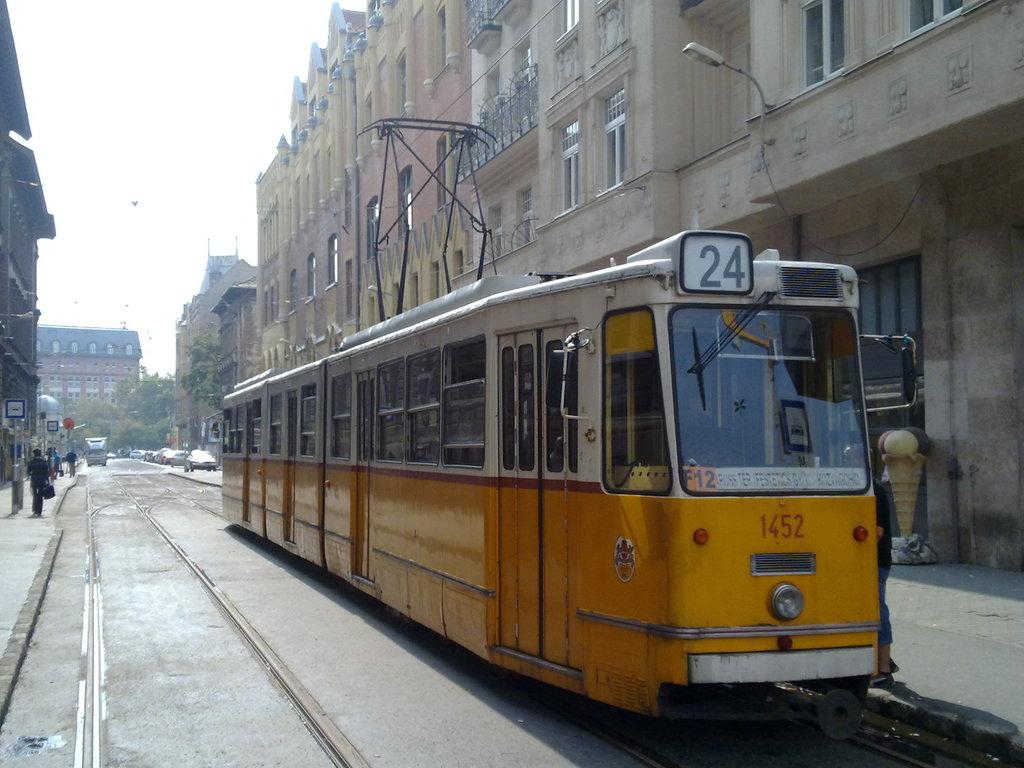What is the train number?
Offer a very short reply. 24. What number is this vehicle?
Give a very brief answer. 24. 